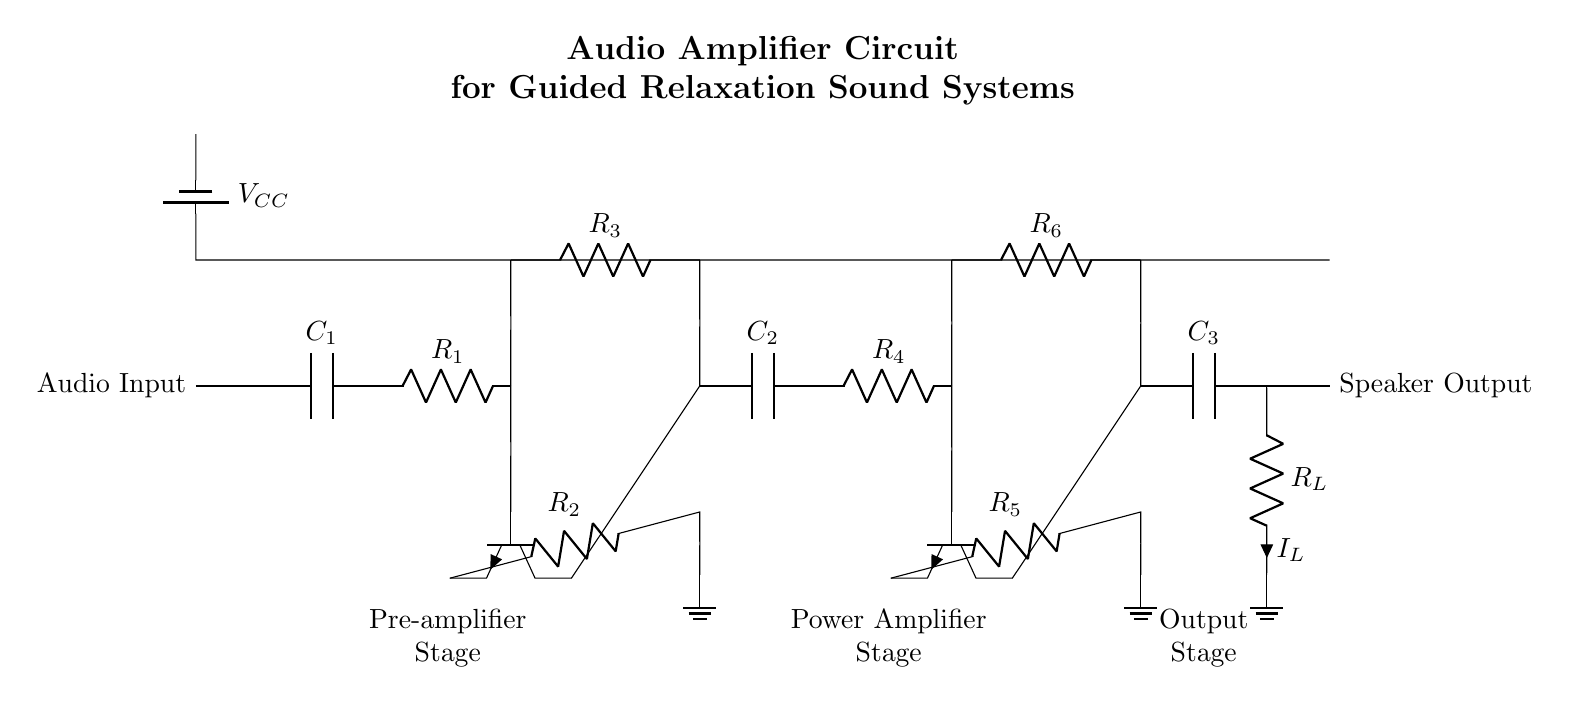What is the role of capacitor C1? Capacitor C1 acts as a coupling capacitor, allowing the audio signal to pass from the input to the pre-amplifier stage while blocking any DC component of the signal.
Answer: Coupling capacitor What type of transistors are used in the circuit? The circuit uses NPN transistors, as indicated by the symbol used in the diagram, which has one arrow pointing out. This indicates that the transistor is an NPN type where current flows from the collector to the emitter when activated.
Answer: NPN How many stages are there in this audio amplifier circuit? The circuit has three main stages: the pre-amplifier stage, the power amplifier stage, and the output stage. Each of these stages is indicated by separate label sections in the diagram.
Answer: Three What is the function of resistor R6? Resistor R6 is connected to the power amplifier stage and is likely used for biasing the transistor, helping to set the operating point and gain of the amplifier.
Answer: Biasing What do the labels VCC and ground represent? VCC indicates the positive power supply voltage that powers the circuit, while ground represents the reference point for the circuit's voltage levels, typically at zero volts.
Answer: Power supply and reference point What is the expected output of this circuit? The expected output of the circuit is the amplified audio signal sent to the speaker, as shown in the connection to the speaker output node at the end of the circuit.
Answer: Amplified audio signal What is the purpose of the component R_L? R_L represents the load resistor for the audio signal output, which in this case, is connected to the speaker. It represents the impedance the amplifier must drive.
Answer: Load resistor 